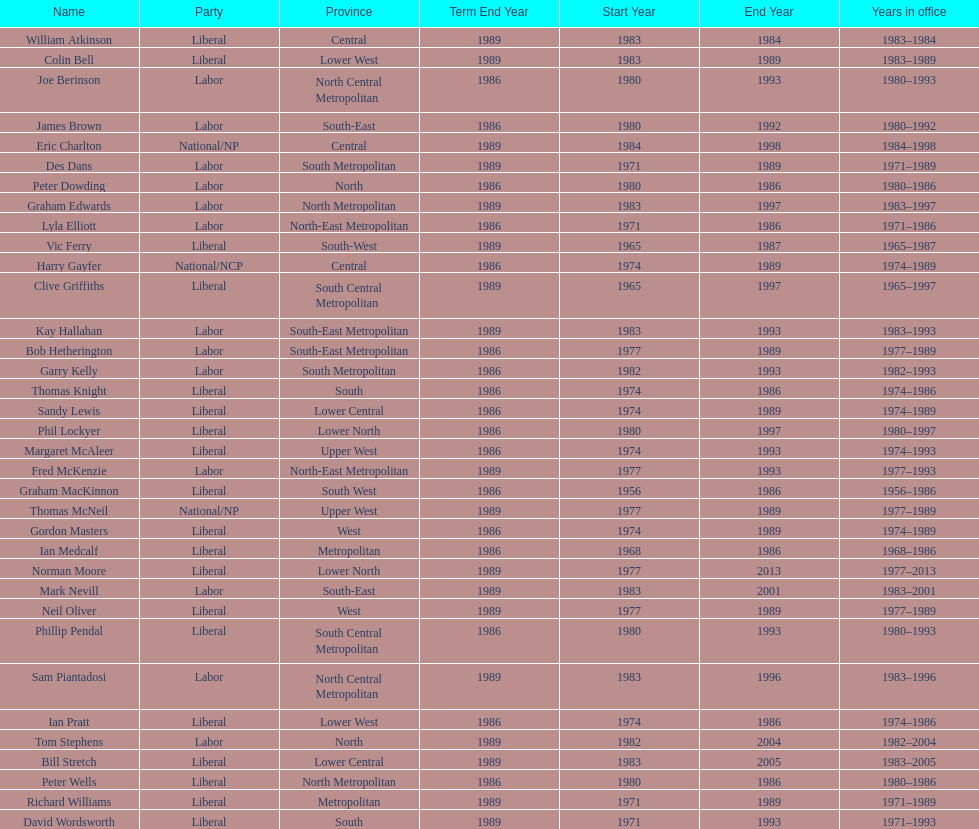How many members were party of lower west province? 2. 